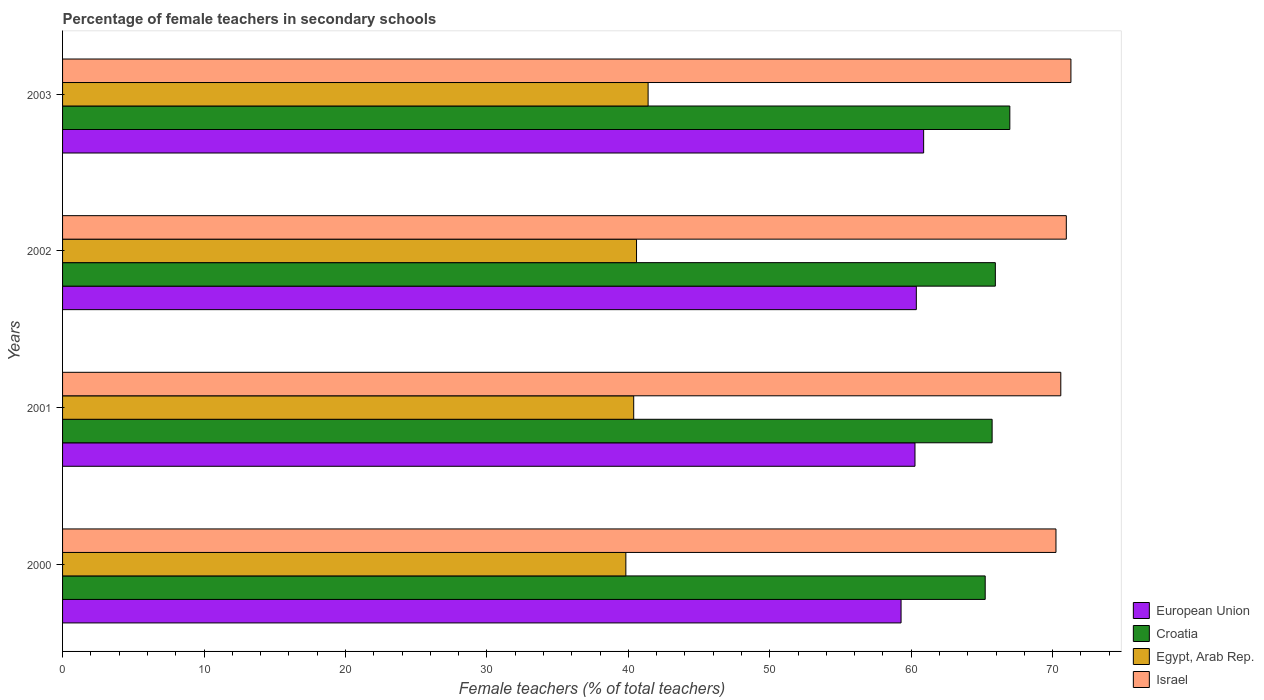How many different coloured bars are there?
Provide a succinct answer. 4. How many groups of bars are there?
Make the answer very short. 4. How many bars are there on the 3rd tick from the top?
Offer a very short reply. 4. How many bars are there on the 3rd tick from the bottom?
Ensure brevity in your answer.  4. What is the label of the 2nd group of bars from the top?
Make the answer very short. 2002. In how many cases, is the number of bars for a given year not equal to the number of legend labels?
Provide a short and direct response. 0. What is the percentage of female teachers in European Union in 2001?
Provide a short and direct response. 60.27. Across all years, what is the maximum percentage of female teachers in European Union?
Make the answer very short. 60.88. Across all years, what is the minimum percentage of female teachers in Croatia?
Ensure brevity in your answer.  65.24. In which year was the percentage of female teachers in Egypt, Arab Rep. minimum?
Give a very brief answer. 2000. What is the total percentage of female teachers in Croatia in the graph?
Give a very brief answer. 263.89. What is the difference between the percentage of female teachers in Egypt, Arab Rep. in 2001 and that in 2003?
Make the answer very short. -1.02. What is the difference between the percentage of female teachers in Egypt, Arab Rep. in 2001 and the percentage of female teachers in Israel in 2002?
Make the answer very short. -30.59. What is the average percentage of female teachers in Israel per year?
Make the answer very short. 70.77. In the year 2000, what is the difference between the percentage of female teachers in Croatia and percentage of female teachers in Israel?
Ensure brevity in your answer.  -5. In how many years, is the percentage of female teachers in Egypt, Arab Rep. greater than 62 %?
Your response must be concise. 0. What is the ratio of the percentage of female teachers in Croatia in 2000 to that in 2003?
Provide a succinct answer. 0.97. Is the percentage of female teachers in Egypt, Arab Rep. in 2001 less than that in 2003?
Your answer should be compact. Yes. What is the difference between the highest and the second highest percentage of female teachers in European Union?
Offer a terse response. 0.52. What is the difference between the highest and the lowest percentage of female teachers in Croatia?
Make the answer very short. 1.74. In how many years, is the percentage of female teachers in Egypt, Arab Rep. greater than the average percentage of female teachers in Egypt, Arab Rep. taken over all years?
Your response must be concise. 2. Is the sum of the percentage of female teachers in Croatia in 2000 and 2002 greater than the maximum percentage of female teachers in European Union across all years?
Provide a succinct answer. Yes. What does the 2nd bar from the top in 2002 represents?
Your answer should be very brief. Egypt, Arab Rep. What does the 3rd bar from the bottom in 2003 represents?
Keep it short and to the point. Egypt, Arab Rep. Are all the bars in the graph horizontal?
Make the answer very short. Yes. How many years are there in the graph?
Offer a terse response. 4. Does the graph contain any zero values?
Ensure brevity in your answer.  No. Does the graph contain grids?
Offer a terse response. No. How many legend labels are there?
Ensure brevity in your answer.  4. How are the legend labels stacked?
Ensure brevity in your answer.  Vertical. What is the title of the graph?
Provide a succinct answer. Percentage of female teachers in secondary schools. What is the label or title of the X-axis?
Ensure brevity in your answer.  Female teachers (% of total teachers). What is the label or title of the Y-axis?
Make the answer very short. Years. What is the Female teachers (% of total teachers) of European Union in 2000?
Offer a very short reply. 59.29. What is the Female teachers (% of total teachers) in Croatia in 2000?
Ensure brevity in your answer.  65.24. What is the Female teachers (% of total teachers) of Egypt, Arab Rep. in 2000?
Your answer should be very brief. 39.83. What is the Female teachers (% of total teachers) of Israel in 2000?
Provide a short and direct response. 70.24. What is the Female teachers (% of total teachers) of European Union in 2001?
Keep it short and to the point. 60.27. What is the Female teachers (% of total teachers) in Croatia in 2001?
Make the answer very short. 65.73. What is the Female teachers (% of total teachers) of Egypt, Arab Rep. in 2001?
Offer a terse response. 40.38. What is the Female teachers (% of total teachers) of Israel in 2001?
Keep it short and to the point. 70.58. What is the Female teachers (% of total teachers) in European Union in 2002?
Offer a terse response. 60.37. What is the Female teachers (% of total teachers) of Croatia in 2002?
Make the answer very short. 65.95. What is the Female teachers (% of total teachers) in Egypt, Arab Rep. in 2002?
Provide a short and direct response. 40.58. What is the Female teachers (% of total teachers) of Israel in 2002?
Ensure brevity in your answer.  70.97. What is the Female teachers (% of total teachers) of European Union in 2003?
Keep it short and to the point. 60.88. What is the Female teachers (% of total teachers) in Croatia in 2003?
Your answer should be compact. 66.98. What is the Female teachers (% of total teachers) of Egypt, Arab Rep. in 2003?
Offer a terse response. 41.4. What is the Female teachers (% of total teachers) of Israel in 2003?
Offer a terse response. 71.3. Across all years, what is the maximum Female teachers (% of total teachers) of European Union?
Your answer should be very brief. 60.88. Across all years, what is the maximum Female teachers (% of total teachers) of Croatia?
Offer a very short reply. 66.98. Across all years, what is the maximum Female teachers (% of total teachers) in Egypt, Arab Rep.?
Offer a terse response. 41.4. Across all years, what is the maximum Female teachers (% of total teachers) in Israel?
Provide a short and direct response. 71.3. Across all years, what is the minimum Female teachers (% of total teachers) in European Union?
Offer a terse response. 59.29. Across all years, what is the minimum Female teachers (% of total teachers) of Croatia?
Offer a very short reply. 65.24. Across all years, what is the minimum Female teachers (% of total teachers) in Egypt, Arab Rep.?
Offer a very short reply. 39.83. Across all years, what is the minimum Female teachers (% of total teachers) in Israel?
Your answer should be compact. 70.24. What is the total Female teachers (% of total teachers) in European Union in the graph?
Provide a succinct answer. 240.81. What is the total Female teachers (% of total teachers) of Croatia in the graph?
Offer a very short reply. 263.89. What is the total Female teachers (% of total teachers) of Egypt, Arab Rep. in the graph?
Offer a very short reply. 162.2. What is the total Female teachers (% of total teachers) in Israel in the graph?
Your answer should be very brief. 283.09. What is the difference between the Female teachers (% of total teachers) of European Union in 2000 and that in 2001?
Offer a very short reply. -0.98. What is the difference between the Female teachers (% of total teachers) of Croatia in 2000 and that in 2001?
Offer a terse response. -0.49. What is the difference between the Female teachers (% of total teachers) in Egypt, Arab Rep. in 2000 and that in 2001?
Keep it short and to the point. -0.55. What is the difference between the Female teachers (% of total teachers) in Israel in 2000 and that in 2001?
Give a very brief answer. -0.34. What is the difference between the Female teachers (% of total teachers) of European Union in 2000 and that in 2002?
Provide a short and direct response. -1.08. What is the difference between the Female teachers (% of total teachers) in Croatia in 2000 and that in 2002?
Your answer should be compact. -0.72. What is the difference between the Female teachers (% of total teachers) in Egypt, Arab Rep. in 2000 and that in 2002?
Provide a short and direct response. -0.75. What is the difference between the Female teachers (% of total teachers) in Israel in 2000 and that in 2002?
Your answer should be very brief. -0.73. What is the difference between the Female teachers (% of total teachers) of European Union in 2000 and that in 2003?
Your answer should be very brief. -1.6. What is the difference between the Female teachers (% of total teachers) in Croatia in 2000 and that in 2003?
Give a very brief answer. -1.74. What is the difference between the Female teachers (% of total teachers) in Egypt, Arab Rep. in 2000 and that in 2003?
Your answer should be very brief. -1.57. What is the difference between the Female teachers (% of total teachers) of Israel in 2000 and that in 2003?
Keep it short and to the point. -1.06. What is the difference between the Female teachers (% of total teachers) of European Union in 2001 and that in 2002?
Your response must be concise. -0.1. What is the difference between the Female teachers (% of total teachers) in Croatia in 2001 and that in 2002?
Provide a short and direct response. -0.23. What is the difference between the Female teachers (% of total teachers) of Egypt, Arab Rep. in 2001 and that in 2002?
Your response must be concise. -0.2. What is the difference between the Female teachers (% of total teachers) in Israel in 2001 and that in 2002?
Your answer should be compact. -0.39. What is the difference between the Female teachers (% of total teachers) of European Union in 2001 and that in 2003?
Provide a succinct answer. -0.61. What is the difference between the Female teachers (% of total teachers) in Croatia in 2001 and that in 2003?
Your response must be concise. -1.25. What is the difference between the Female teachers (% of total teachers) in Egypt, Arab Rep. in 2001 and that in 2003?
Your response must be concise. -1.02. What is the difference between the Female teachers (% of total teachers) of Israel in 2001 and that in 2003?
Provide a short and direct response. -0.72. What is the difference between the Female teachers (% of total teachers) of European Union in 2002 and that in 2003?
Your answer should be compact. -0.52. What is the difference between the Female teachers (% of total teachers) of Croatia in 2002 and that in 2003?
Ensure brevity in your answer.  -1.02. What is the difference between the Female teachers (% of total teachers) of Egypt, Arab Rep. in 2002 and that in 2003?
Your answer should be very brief. -0.82. What is the difference between the Female teachers (% of total teachers) of Israel in 2002 and that in 2003?
Your answer should be very brief. -0.33. What is the difference between the Female teachers (% of total teachers) in European Union in 2000 and the Female teachers (% of total teachers) in Croatia in 2001?
Your response must be concise. -6.44. What is the difference between the Female teachers (% of total teachers) of European Union in 2000 and the Female teachers (% of total teachers) of Egypt, Arab Rep. in 2001?
Give a very brief answer. 18.9. What is the difference between the Female teachers (% of total teachers) of European Union in 2000 and the Female teachers (% of total teachers) of Israel in 2001?
Offer a very short reply. -11.29. What is the difference between the Female teachers (% of total teachers) of Croatia in 2000 and the Female teachers (% of total teachers) of Egypt, Arab Rep. in 2001?
Offer a very short reply. 24.85. What is the difference between the Female teachers (% of total teachers) of Croatia in 2000 and the Female teachers (% of total teachers) of Israel in 2001?
Your answer should be very brief. -5.35. What is the difference between the Female teachers (% of total teachers) in Egypt, Arab Rep. in 2000 and the Female teachers (% of total teachers) in Israel in 2001?
Ensure brevity in your answer.  -30.75. What is the difference between the Female teachers (% of total teachers) of European Union in 2000 and the Female teachers (% of total teachers) of Croatia in 2002?
Make the answer very short. -6.67. What is the difference between the Female teachers (% of total teachers) in European Union in 2000 and the Female teachers (% of total teachers) in Egypt, Arab Rep. in 2002?
Provide a short and direct response. 18.7. What is the difference between the Female teachers (% of total teachers) of European Union in 2000 and the Female teachers (% of total teachers) of Israel in 2002?
Provide a succinct answer. -11.68. What is the difference between the Female teachers (% of total teachers) of Croatia in 2000 and the Female teachers (% of total teachers) of Egypt, Arab Rep. in 2002?
Your response must be concise. 24.65. What is the difference between the Female teachers (% of total teachers) of Croatia in 2000 and the Female teachers (% of total teachers) of Israel in 2002?
Provide a short and direct response. -5.74. What is the difference between the Female teachers (% of total teachers) in Egypt, Arab Rep. in 2000 and the Female teachers (% of total teachers) in Israel in 2002?
Your answer should be compact. -31.14. What is the difference between the Female teachers (% of total teachers) in European Union in 2000 and the Female teachers (% of total teachers) in Croatia in 2003?
Give a very brief answer. -7.69. What is the difference between the Female teachers (% of total teachers) of European Union in 2000 and the Female teachers (% of total teachers) of Egypt, Arab Rep. in 2003?
Your answer should be compact. 17.89. What is the difference between the Female teachers (% of total teachers) of European Union in 2000 and the Female teachers (% of total teachers) of Israel in 2003?
Provide a succinct answer. -12.01. What is the difference between the Female teachers (% of total teachers) in Croatia in 2000 and the Female teachers (% of total teachers) in Egypt, Arab Rep. in 2003?
Keep it short and to the point. 23.83. What is the difference between the Female teachers (% of total teachers) of Croatia in 2000 and the Female teachers (% of total teachers) of Israel in 2003?
Your answer should be very brief. -6.06. What is the difference between the Female teachers (% of total teachers) of Egypt, Arab Rep. in 2000 and the Female teachers (% of total teachers) of Israel in 2003?
Offer a terse response. -31.47. What is the difference between the Female teachers (% of total teachers) of European Union in 2001 and the Female teachers (% of total teachers) of Croatia in 2002?
Your answer should be compact. -5.68. What is the difference between the Female teachers (% of total teachers) in European Union in 2001 and the Female teachers (% of total teachers) in Egypt, Arab Rep. in 2002?
Offer a terse response. 19.69. What is the difference between the Female teachers (% of total teachers) of European Union in 2001 and the Female teachers (% of total teachers) of Israel in 2002?
Offer a terse response. -10.7. What is the difference between the Female teachers (% of total teachers) in Croatia in 2001 and the Female teachers (% of total teachers) in Egypt, Arab Rep. in 2002?
Your response must be concise. 25.14. What is the difference between the Female teachers (% of total teachers) of Croatia in 2001 and the Female teachers (% of total teachers) of Israel in 2002?
Make the answer very short. -5.25. What is the difference between the Female teachers (% of total teachers) in Egypt, Arab Rep. in 2001 and the Female teachers (% of total teachers) in Israel in 2002?
Provide a short and direct response. -30.59. What is the difference between the Female teachers (% of total teachers) of European Union in 2001 and the Female teachers (% of total teachers) of Croatia in 2003?
Ensure brevity in your answer.  -6.71. What is the difference between the Female teachers (% of total teachers) of European Union in 2001 and the Female teachers (% of total teachers) of Egypt, Arab Rep. in 2003?
Offer a terse response. 18.87. What is the difference between the Female teachers (% of total teachers) in European Union in 2001 and the Female teachers (% of total teachers) in Israel in 2003?
Your answer should be compact. -11.03. What is the difference between the Female teachers (% of total teachers) in Croatia in 2001 and the Female teachers (% of total teachers) in Egypt, Arab Rep. in 2003?
Offer a very short reply. 24.32. What is the difference between the Female teachers (% of total teachers) in Croatia in 2001 and the Female teachers (% of total teachers) in Israel in 2003?
Keep it short and to the point. -5.57. What is the difference between the Female teachers (% of total teachers) in Egypt, Arab Rep. in 2001 and the Female teachers (% of total teachers) in Israel in 2003?
Ensure brevity in your answer.  -30.91. What is the difference between the Female teachers (% of total teachers) in European Union in 2002 and the Female teachers (% of total teachers) in Croatia in 2003?
Your response must be concise. -6.61. What is the difference between the Female teachers (% of total teachers) of European Union in 2002 and the Female teachers (% of total teachers) of Egypt, Arab Rep. in 2003?
Make the answer very short. 18.96. What is the difference between the Female teachers (% of total teachers) of European Union in 2002 and the Female teachers (% of total teachers) of Israel in 2003?
Make the answer very short. -10.93. What is the difference between the Female teachers (% of total teachers) in Croatia in 2002 and the Female teachers (% of total teachers) in Egypt, Arab Rep. in 2003?
Ensure brevity in your answer.  24.55. What is the difference between the Female teachers (% of total teachers) of Croatia in 2002 and the Female teachers (% of total teachers) of Israel in 2003?
Your response must be concise. -5.34. What is the difference between the Female teachers (% of total teachers) in Egypt, Arab Rep. in 2002 and the Female teachers (% of total teachers) in Israel in 2003?
Give a very brief answer. -30.71. What is the average Female teachers (% of total teachers) in European Union per year?
Make the answer very short. 60.2. What is the average Female teachers (% of total teachers) in Croatia per year?
Ensure brevity in your answer.  65.97. What is the average Female teachers (% of total teachers) of Egypt, Arab Rep. per year?
Offer a terse response. 40.55. What is the average Female teachers (% of total teachers) of Israel per year?
Keep it short and to the point. 70.77. In the year 2000, what is the difference between the Female teachers (% of total teachers) in European Union and Female teachers (% of total teachers) in Croatia?
Give a very brief answer. -5.95. In the year 2000, what is the difference between the Female teachers (% of total teachers) in European Union and Female teachers (% of total teachers) in Egypt, Arab Rep.?
Your answer should be very brief. 19.46. In the year 2000, what is the difference between the Female teachers (% of total teachers) in European Union and Female teachers (% of total teachers) in Israel?
Keep it short and to the point. -10.95. In the year 2000, what is the difference between the Female teachers (% of total teachers) of Croatia and Female teachers (% of total teachers) of Egypt, Arab Rep.?
Keep it short and to the point. 25.41. In the year 2000, what is the difference between the Female teachers (% of total teachers) in Croatia and Female teachers (% of total teachers) in Israel?
Your answer should be compact. -5. In the year 2000, what is the difference between the Female teachers (% of total teachers) in Egypt, Arab Rep. and Female teachers (% of total teachers) in Israel?
Offer a very short reply. -30.41. In the year 2001, what is the difference between the Female teachers (% of total teachers) in European Union and Female teachers (% of total teachers) in Croatia?
Provide a succinct answer. -5.45. In the year 2001, what is the difference between the Female teachers (% of total teachers) of European Union and Female teachers (% of total teachers) of Egypt, Arab Rep.?
Make the answer very short. 19.89. In the year 2001, what is the difference between the Female teachers (% of total teachers) in European Union and Female teachers (% of total teachers) in Israel?
Provide a succinct answer. -10.31. In the year 2001, what is the difference between the Female teachers (% of total teachers) of Croatia and Female teachers (% of total teachers) of Egypt, Arab Rep.?
Your response must be concise. 25.34. In the year 2001, what is the difference between the Female teachers (% of total teachers) in Croatia and Female teachers (% of total teachers) in Israel?
Provide a short and direct response. -4.86. In the year 2001, what is the difference between the Female teachers (% of total teachers) of Egypt, Arab Rep. and Female teachers (% of total teachers) of Israel?
Ensure brevity in your answer.  -30.2. In the year 2002, what is the difference between the Female teachers (% of total teachers) in European Union and Female teachers (% of total teachers) in Croatia?
Your response must be concise. -5.59. In the year 2002, what is the difference between the Female teachers (% of total teachers) of European Union and Female teachers (% of total teachers) of Egypt, Arab Rep.?
Give a very brief answer. 19.78. In the year 2002, what is the difference between the Female teachers (% of total teachers) of European Union and Female teachers (% of total teachers) of Israel?
Provide a succinct answer. -10.61. In the year 2002, what is the difference between the Female teachers (% of total teachers) in Croatia and Female teachers (% of total teachers) in Egypt, Arab Rep.?
Offer a terse response. 25.37. In the year 2002, what is the difference between the Female teachers (% of total teachers) in Croatia and Female teachers (% of total teachers) in Israel?
Provide a short and direct response. -5.02. In the year 2002, what is the difference between the Female teachers (% of total teachers) of Egypt, Arab Rep. and Female teachers (% of total teachers) of Israel?
Your response must be concise. -30.39. In the year 2003, what is the difference between the Female teachers (% of total teachers) in European Union and Female teachers (% of total teachers) in Croatia?
Your answer should be compact. -6.09. In the year 2003, what is the difference between the Female teachers (% of total teachers) in European Union and Female teachers (% of total teachers) in Egypt, Arab Rep.?
Your answer should be very brief. 19.48. In the year 2003, what is the difference between the Female teachers (% of total teachers) of European Union and Female teachers (% of total teachers) of Israel?
Provide a succinct answer. -10.41. In the year 2003, what is the difference between the Female teachers (% of total teachers) of Croatia and Female teachers (% of total teachers) of Egypt, Arab Rep.?
Offer a terse response. 25.58. In the year 2003, what is the difference between the Female teachers (% of total teachers) in Croatia and Female teachers (% of total teachers) in Israel?
Your answer should be compact. -4.32. In the year 2003, what is the difference between the Female teachers (% of total teachers) of Egypt, Arab Rep. and Female teachers (% of total teachers) of Israel?
Your answer should be compact. -29.9. What is the ratio of the Female teachers (% of total teachers) of European Union in 2000 to that in 2001?
Your answer should be very brief. 0.98. What is the ratio of the Female teachers (% of total teachers) in Croatia in 2000 to that in 2001?
Your answer should be compact. 0.99. What is the ratio of the Female teachers (% of total teachers) in Egypt, Arab Rep. in 2000 to that in 2001?
Make the answer very short. 0.99. What is the ratio of the Female teachers (% of total teachers) of European Union in 2000 to that in 2002?
Keep it short and to the point. 0.98. What is the ratio of the Female teachers (% of total teachers) in Egypt, Arab Rep. in 2000 to that in 2002?
Provide a short and direct response. 0.98. What is the ratio of the Female teachers (% of total teachers) of European Union in 2000 to that in 2003?
Offer a terse response. 0.97. What is the ratio of the Female teachers (% of total teachers) in Egypt, Arab Rep. in 2000 to that in 2003?
Keep it short and to the point. 0.96. What is the ratio of the Female teachers (% of total teachers) of Israel in 2000 to that in 2003?
Offer a very short reply. 0.99. What is the ratio of the Female teachers (% of total teachers) of European Union in 2001 to that in 2002?
Make the answer very short. 1. What is the ratio of the Female teachers (% of total teachers) in Croatia in 2001 to that in 2002?
Offer a very short reply. 1. What is the ratio of the Female teachers (% of total teachers) in Egypt, Arab Rep. in 2001 to that in 2002?
Provide a succinct answer. 1. What is the ratio of the Female teachers (% of total teachers) of Israel in 2001 to that in 2002?
Ensure brevity in your answer.  0.99. What is the ratio of the Female teachers (% of total teachers) in European Union in 2001 to that in 2003?
Your answer should be compact. 0.99. What is the ratio of the Female teachers (% of total teachers) in Croatia in 2001 to that in 2003?
Make the answer very short. 0.98. What is the ratio of the Female teachers (% of total teachers) in Egypt, Arab Rep. in 2001 to that in 2003?
Provide a short and direct response. 0.98. What is the ratio of the Female teachers (% of total teachers) of Croatia in 2002 to that in 2003?
Your response must be concise. 0.98. What is the ratio of the Female teachers (% of total teachers) in Egypt, Arab Rep. in 2002 to that in 2003?
Make the answer very short. 0.98. What is the ratio of the Female teachers (% of total teachers) of Israel in 2002 to that in 2003?
Ensure brevity in your answer.  1. What is the difference between the highest and the second highest Female teachers (% of total teachers) in European Union?
Make the answer very short. 0.52. What is the difference between the highest and the second highest Female teachers (% of total teachers) of Croatia?
Your answer should be very brief. 1.02. What is the difference between the highest and the second highest Female teachers (% of total teachers) of Egypt, Arab Rep.?
Keep it short and to the point. 0.82. What is the difference between the highest and the second highest Female teachers (% of total teachers) of Israel?
Give a very brief answer. 0.33. What is the difference between the highest and the lowest Female teachers (% of total teachers) of European Union?
Ensure brevity in your answer.  1.6. What is the difference between the highest and the lowest Female teachers (% of total teachers) of Croatia?
Offer a very short reply. 1.74. What is the difference between the highest and the lowest Female teachers (% of total teachers) in Egypt, Arab Rep.?
Ensure brevity in your answer.  1.57. What is the difference between the highest and the lowest Female teachers (% of total teachers) of Israel?
Your response must be concise. 1.06. 